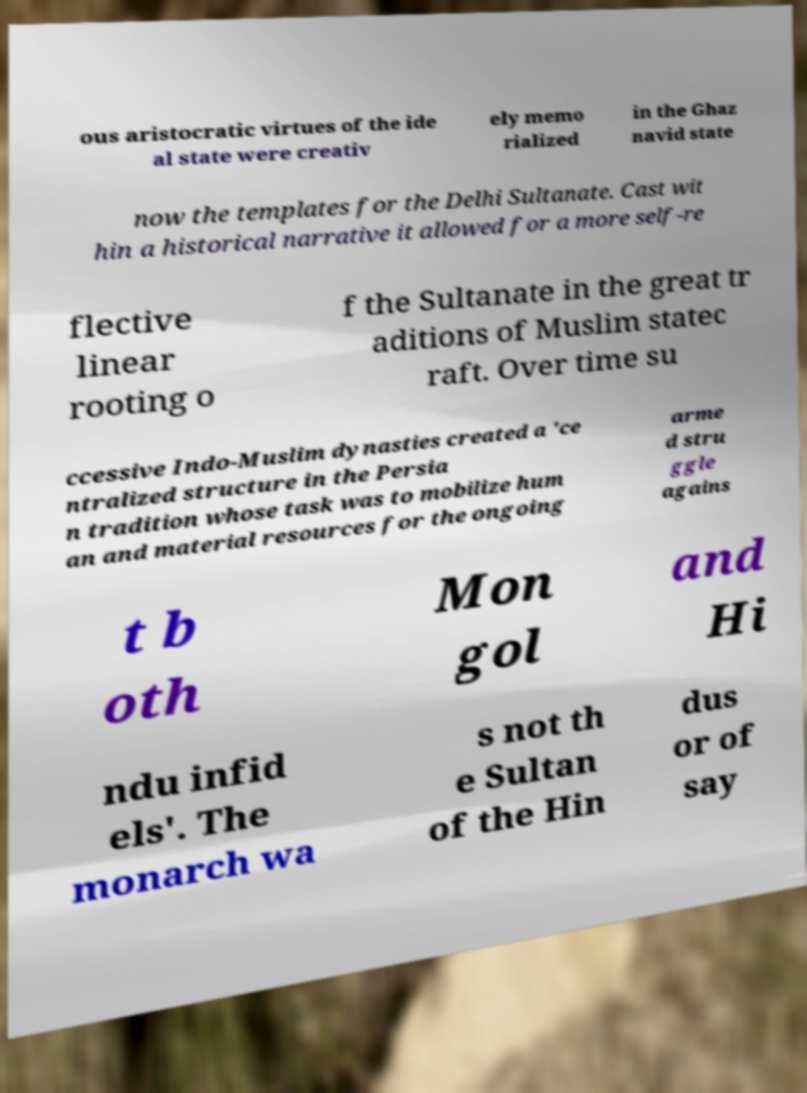What messages or text are displayed in this image? I need them in a readable, typed format. ous aristocratic virtues of the ide al state were creativ ely memo rialized in the Ghaz navid state now the templates for the Delhi Sultanate. Cast wit hin a historical narrative it allowed for a more self-re flective linear rooting o f the Sultanate in the great tr aditions of Muslim statec raft. Over time su ccessive Indo-Muslim dynasties created a 'ce ntralized structure in the Persia n tradition whose task was to mobilize hum an and material resources for the ongoing arme d stru ggle agains t b oth Mon gol and Hi ndu infid els'. The monarch wa s not th e Sultan of the Hin dus or of say 